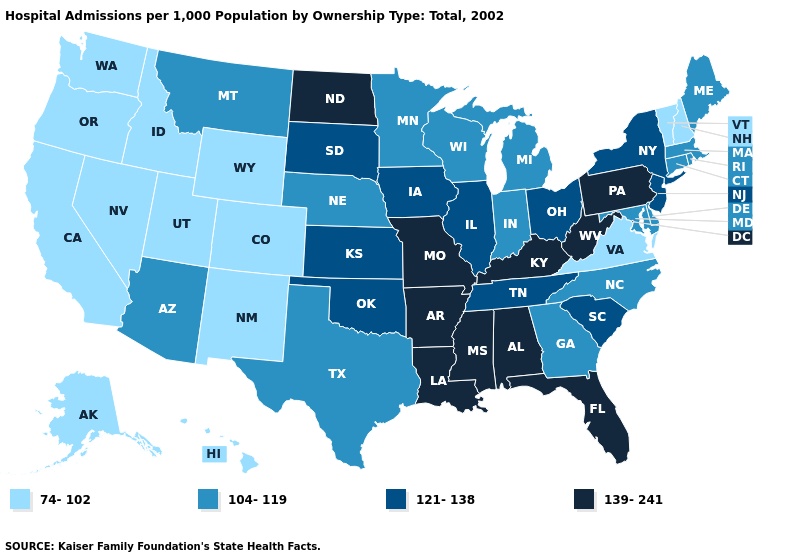Does the map have missing data?
Short answer required. No. Name the states that have a value in the range 139-241?
Write a very short answer. Alabama, Arkansas, Florida, Kentucky, Louisiana, Mississippi, Missouri, North Dakota, Pennsylvania, West Virginia. What is the highest value in states that border Texas?
Give a very brief answer. 139-241. Name the states that have a value in the range 74-102?
Concise answer only. Alaska, California, Colorado, Hawaii, Idaho, Nevada, New Hampshire, New Mexico, Oregon, Utah, Vermont, Virginia, Washington, Wyoming. Is the legend a continuous bar?
Answer briefly. No. Does the map have missing data?
Be succinct. No. How many symbols are there in the legend?
Answer briefly. 4. What is the highest value in the MidWest ?
Short answer required. 139-241. Name the states that have a value in the range 139-241?
Answer briefly. Alabama, Arkansas, Florida, Kentucky, Louisiana, Mississippi, Missouri, North Dakota, Pennsylvania, West Virginia. Among the states that border California , which have the highest value?
Write a very short answer. Arizona. Name the states that have a value in the range 104-119?
Concise answer only. Arizona, Connecticut, Delaware, Georgia, Indiana, Maine, Maryland, Massachusetts, Michigan, Minnesota, Montana, Nebraska, North Carolina, Rhode Island, Texas, Wisconsin. What is the value of Maine?
Write a very short answer. 104-119. Among the states that border Arkansas , does Tennessee have the highest value?
Keep it brief. No. Does the first symbol in the legend represent the smallest category?
Concise answer only. Yes. Name the states that have a value in the range 139-241?
Write a very short answer. Alabama, Arkansas, Florida, Kentucky, Louisiana, Mississippi, Missouri, North Dakota, Pennsylvania, West Virginia. 